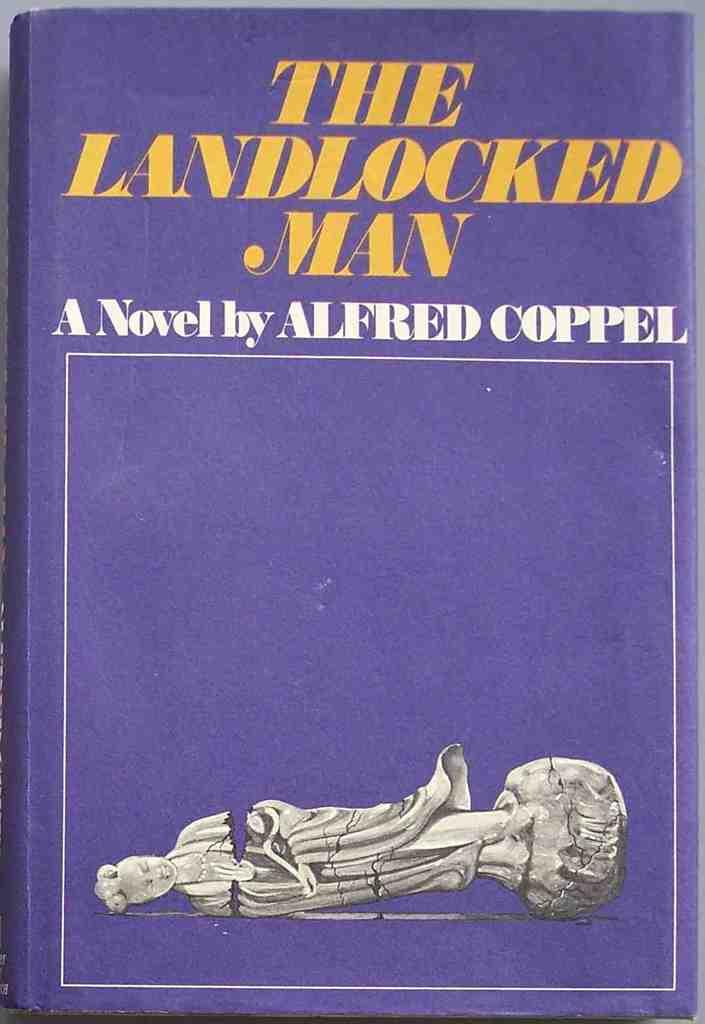<image>
Give a short and clear explanation of the subsequent image. purple colored novel titled the landlocked man with picture of broken statue on the fron 